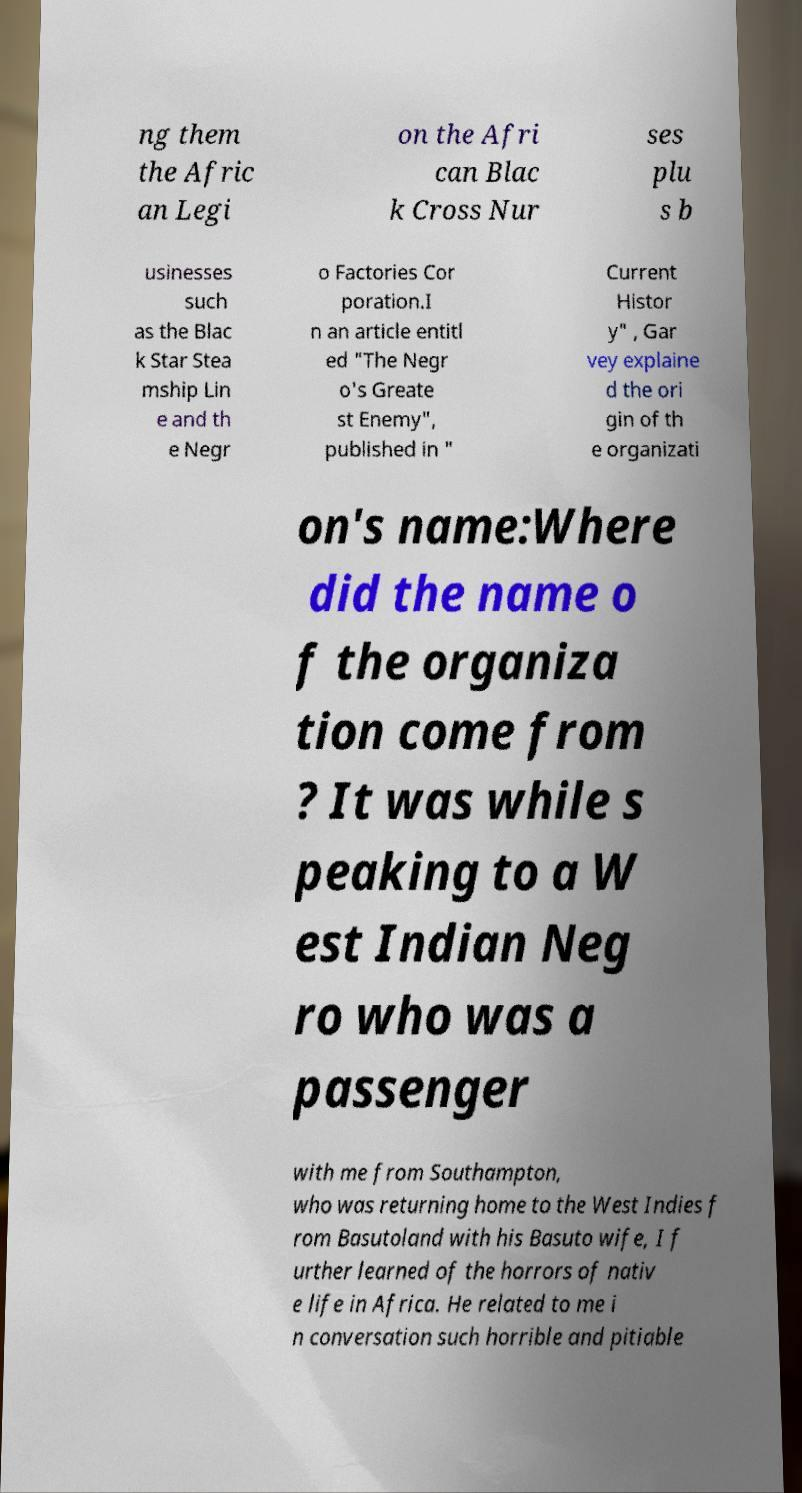Could you assist in decoding the text presented in this image and type it out clearly? ng them the Afric an Legi on the Afri can Blac k Cross Nur ses plu s b usinesses such as the Blac k Star Stea mship Lin e and th e Negr o Factories Cor poration.I n an article entitl ed "The Negr o's Greate st Enemy", published in " Current Histor y" , Gar vey explaine d the ori gin of th e organizati on's name:Where did the name o f the organiza tion come from ? It was while s peaking to a W est Indian Neg ro who was a passenger with me from Southampton, who was returning home to the West Indies f rom Basutoland with his Basuto wife, I f urther learned of the horrors of nativ e life in Africa. He related to me i n conversation such horrible and pitiable 